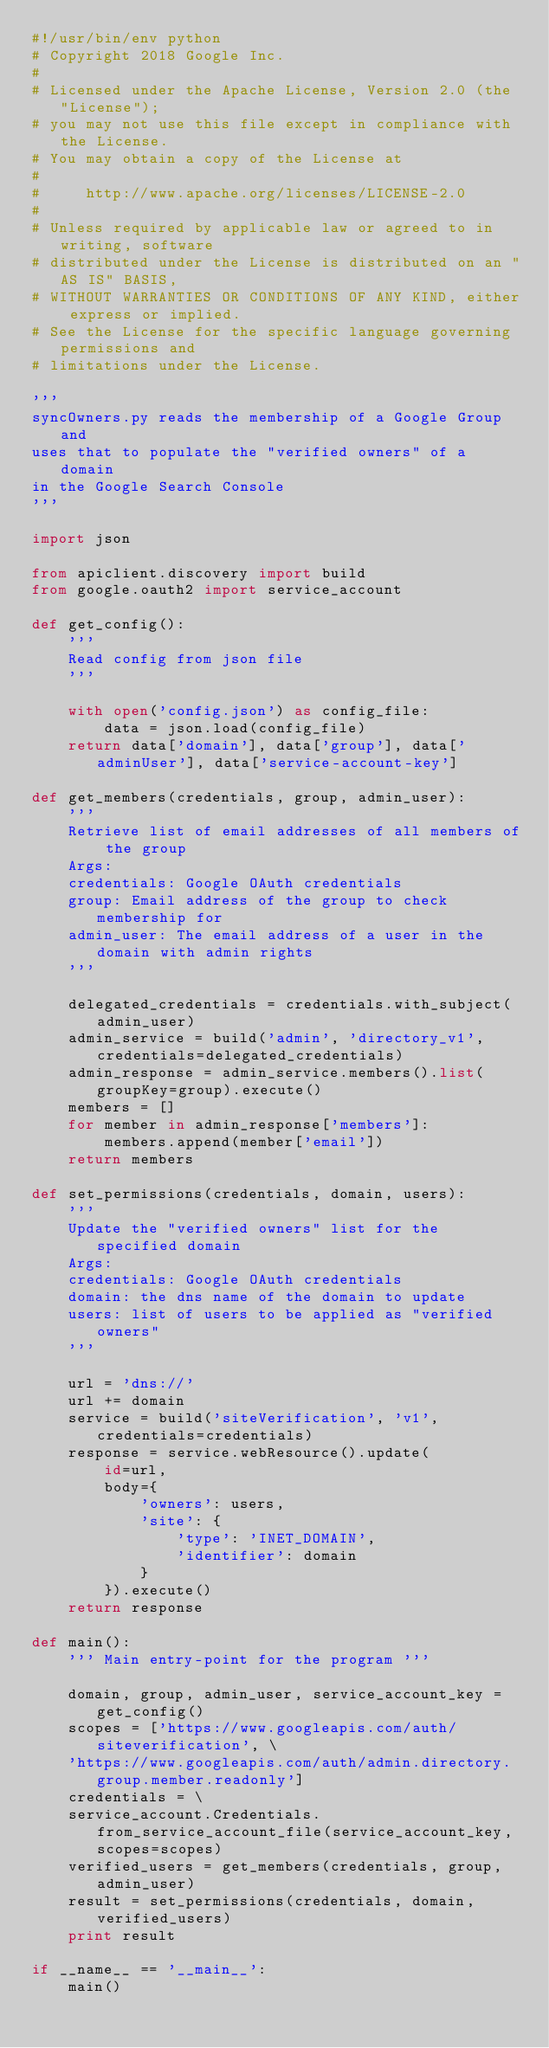<code> <loc_0><loc_0><loc_500><loc_500><_Python_>#!/usr/bin/env python
# Copyright 2018 Google Inc.
#
# Licensed under the Apache License, Version 2.0 (the "License");
# you may not use this file except in compliance with the License.
# You may obtain a copy of the License at
#
#     http://www.apache.org/licenses/LICENSE-2.0
#
# Unless required by applicable law or agreed to in writing, software
# distributed under the License is distributed on an "AS IS" BASIS,
# WITHOUT WARRANTIES OR CONDITIONS OF ANY KIND, either express or implied.
# See the License for the specific language governing permissions and
# limitations under the License.

'''
syncOwners.py reads the membership of a Google Group and
uses that to populate the "verified owners" of a domain
in the Google Search Console
'''

import json

from apiclient.discovery import build
from google.oauth2 import service_account

def get_config():
    '''
    Read config from json file
    '''

    with open('config.json') as config_file:
        data = json.load(config_file)
    return data['domain'], data['group'], data['adminUser'], data['service-account-key']

def get_members(credentials, group, admin_user):
    '''
    Retrieve list of email addresses of all members of the group
    Args:
    credentials: Google OAuth credentials
    group: Email address of the group to check membership for
    admin_user: The email address of a user in the domain with admin rights
    '''

    delegated_credentials = credentials.with_subject(admin_user)
    admin_service = build('admin', 'directory_v1', credentials=delegated_credentials)
    admin_response = admin_service.members().list(groupKey=group).execute()
    members = []
    for member in admin_response['members']:
        members.append(member['email'])
    return members

def set_permissions(credentials, domain, users):
    '''
    Update the "verified owners" list for the specified domain
    Args:
    credentials: Google OAuth credentials
    domain: the dns name of the domain to update
    users: list of users to be applied as "verified owners"
    '''

    url = 'dns://'
    url += domain
    service = build('siteVerification', 'v1', credentials=credentials)
    response = service.webResource().update(
        id=url,
        body={
            'owners': users,
            'site': {
                'type': 'INET_DOMAIN',
                'identifier': domain
            }
        }).execute()
    return response

def main():
    ''' Main entry-point for the program '''

    domain, group, admin_user, service_account_key = get_config()
    scopes = ['https://www.googleapis.com/auth/siteverification', \
    'https://www.googleapis.com/auth/admin.directory.group.member.readonly']
    credentials = \
    service_account.Credentials.from_service_account_file(service_account_key, scopes=scopes)
    verified_users = get_members(credentials, group, admin_user)
    result = set_permissions(credentials, domain, verified_users)
    print result

if __name__ == '__main__':
    main()
</code> 